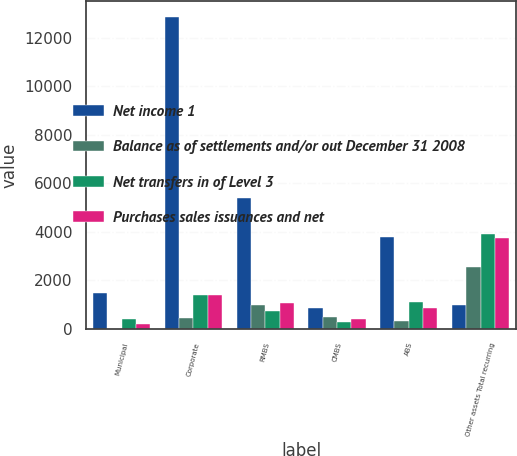Convert chart. <chart><loc_0><loc_0><loc_500><loc_500><stacked_bar_chart><ecel><fcel>Municipal<fcel>Corporate<fcel>RMBS<fcel>CMBS<fcel>ABS<fcel>Other assets Total recurring<nl><fcel>Net income 1<fcel>1477<fcel>12868<fcel>5405<fcel>833<fcel>3769<fcel>971<nl><fcel>Balance as of settlements and/or out December 31 2008<fcel>3<fcel>426<fcel>971<fcel>479<fcel>316<fcel>2525<nl><fcel>Net transfers in of Level 3<fcel>385<fcel>1402<fcel>731<fcel>291<fcel>1106<fcel>3910<nl><fcel>Purchases sales issuances and net<fcel>205<fcel>1371<fcel>1058<fcel>383<fcel>853<fcel>3732<nl></chart> 